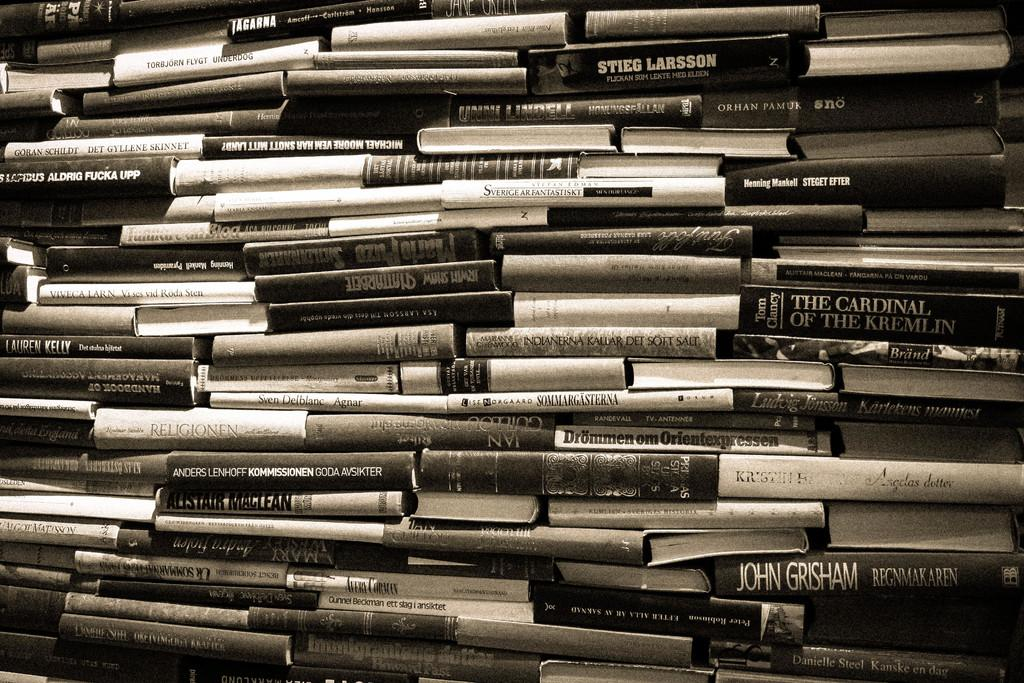<image>
Create a compact narrative representing the image presented. a book with the word goda on the side of it 